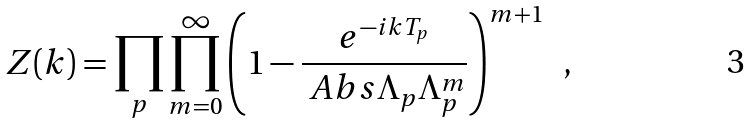<formula> <loc_0><loc_0><loc_500><loc_500>Z ( k ) = \prod _ { p } \prod _ { m = 0 } ^ { \infty } \left ( 1 - \frac { e ^ { - i k T _ { p } } } { \ A b s { \Lambda _ { p } } \Lambda _ { p } ^ { m } } \right ) ^ { m + 1 } \ \ ,</formula> 